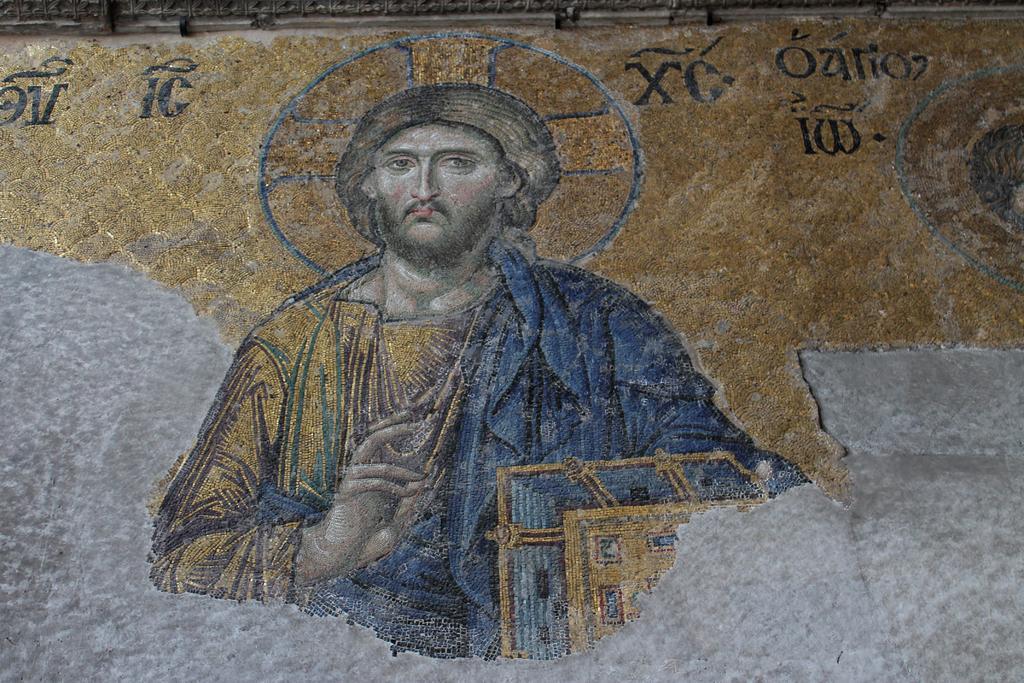In one or two sentences, can you explain what this image depicts? In the picture we can see a rock wall on it we can see a painting of Jesus. 